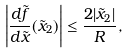<formula> <loc_0><loc_0><loc_500><loc_500>\left | \frac { d \tilde { f } } { d \tilde { x } } ( \tilde { x } _ { 2 } ) \right | \leq \frac { 2 | \tilde { x } _ { 2 } | } { R } ,</formula> 